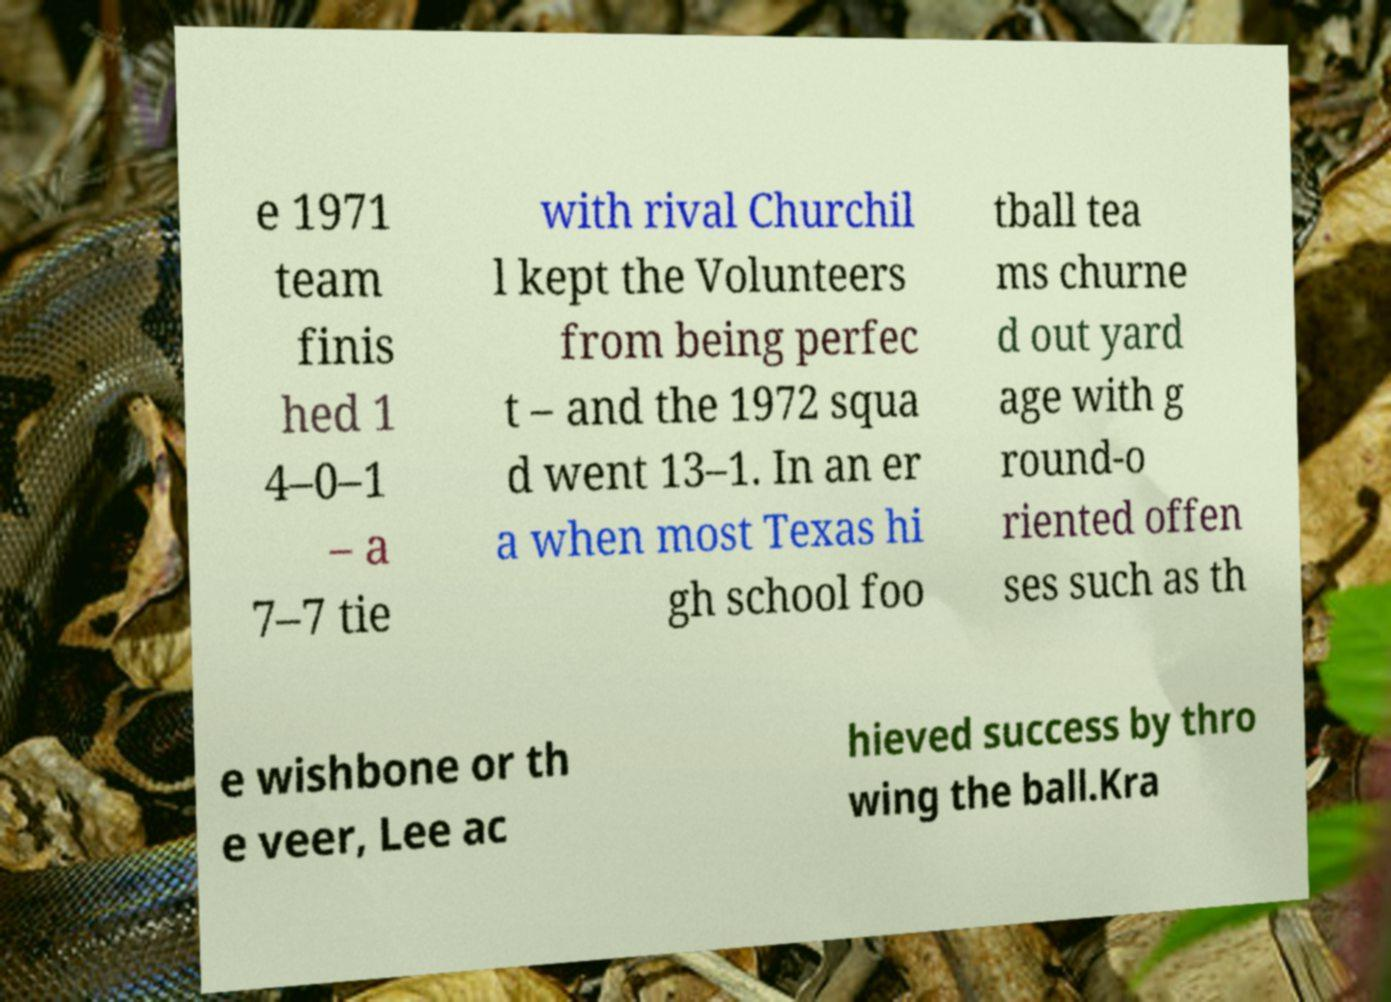What messages or text are displayed in this image? I need them in a readable, typed format. e 1971 team finis hed 1 4–0–1 – a 7–7 tie with rival Churchil l kept the Volunteers from being perfec t – and the 1972 squa d went 13–1. In an er a when most Texas hi gh school foo tball tea ms churne d out yard age with g round-o riented offen ses such as th e wishbone or th e veer, Lee ac hieved success by thro wing the ball.Kra 